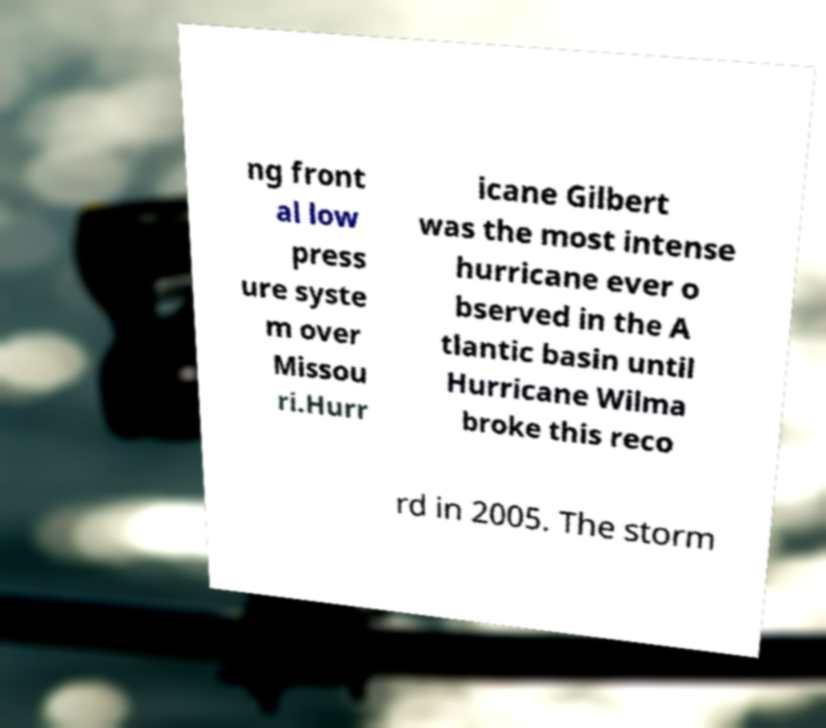Can you accurately transcribe the text from the provided image for me? ng front al low press ure syste m over Missou ri.Hurr icane Gilbert was the most intense hurricane ever o bserved in the A tlantic basin until Hurricane Wilma broke this reco rd in 2005. The storm 